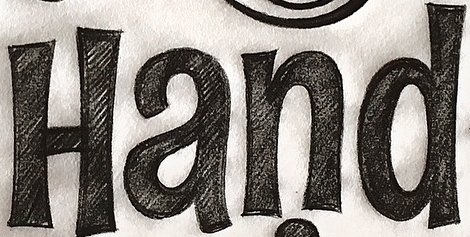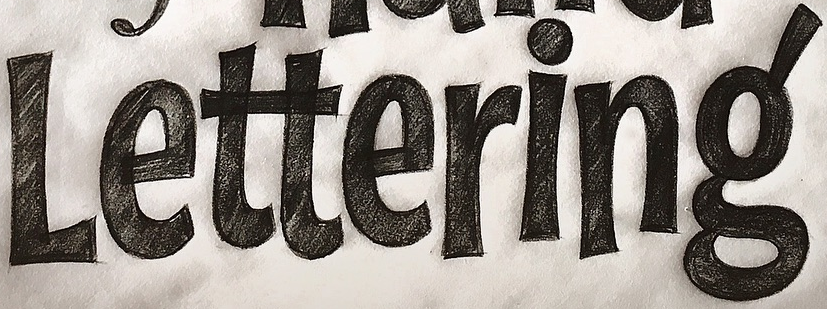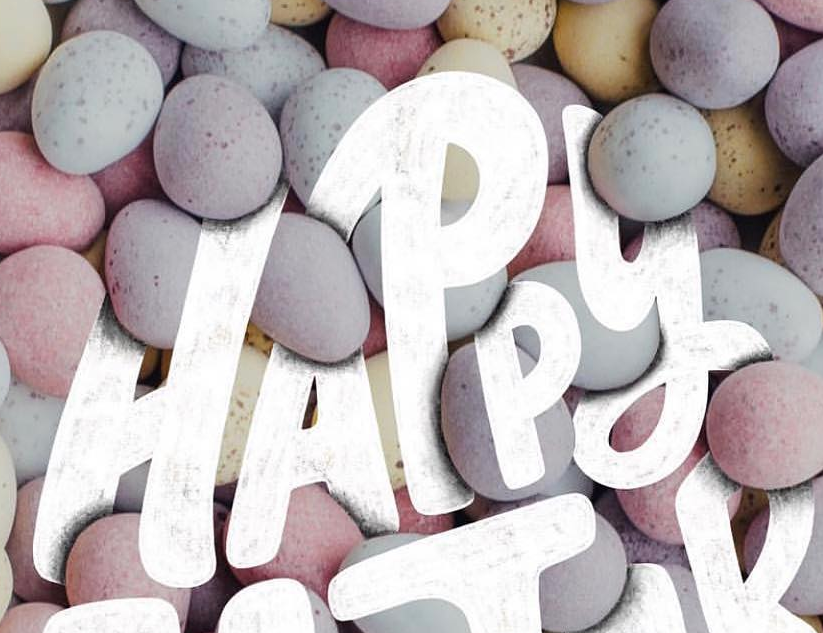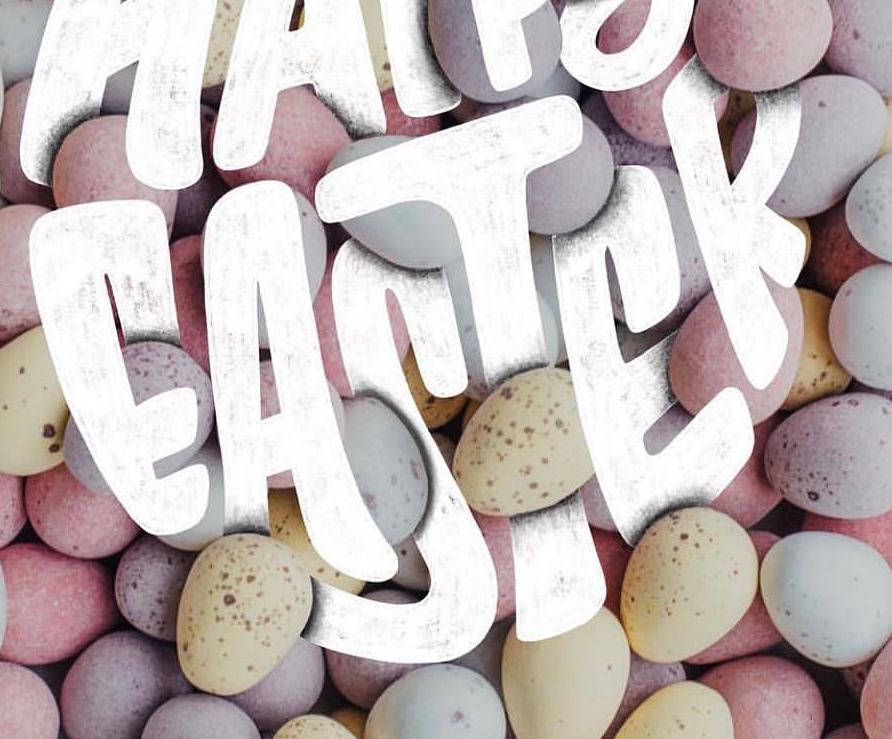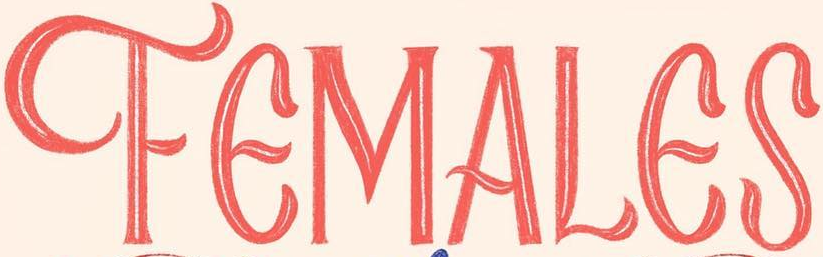What words are shown in these images in order, separated by a semicolon? Hand; Lettering; HAPPY; EASTER; FEMALES 